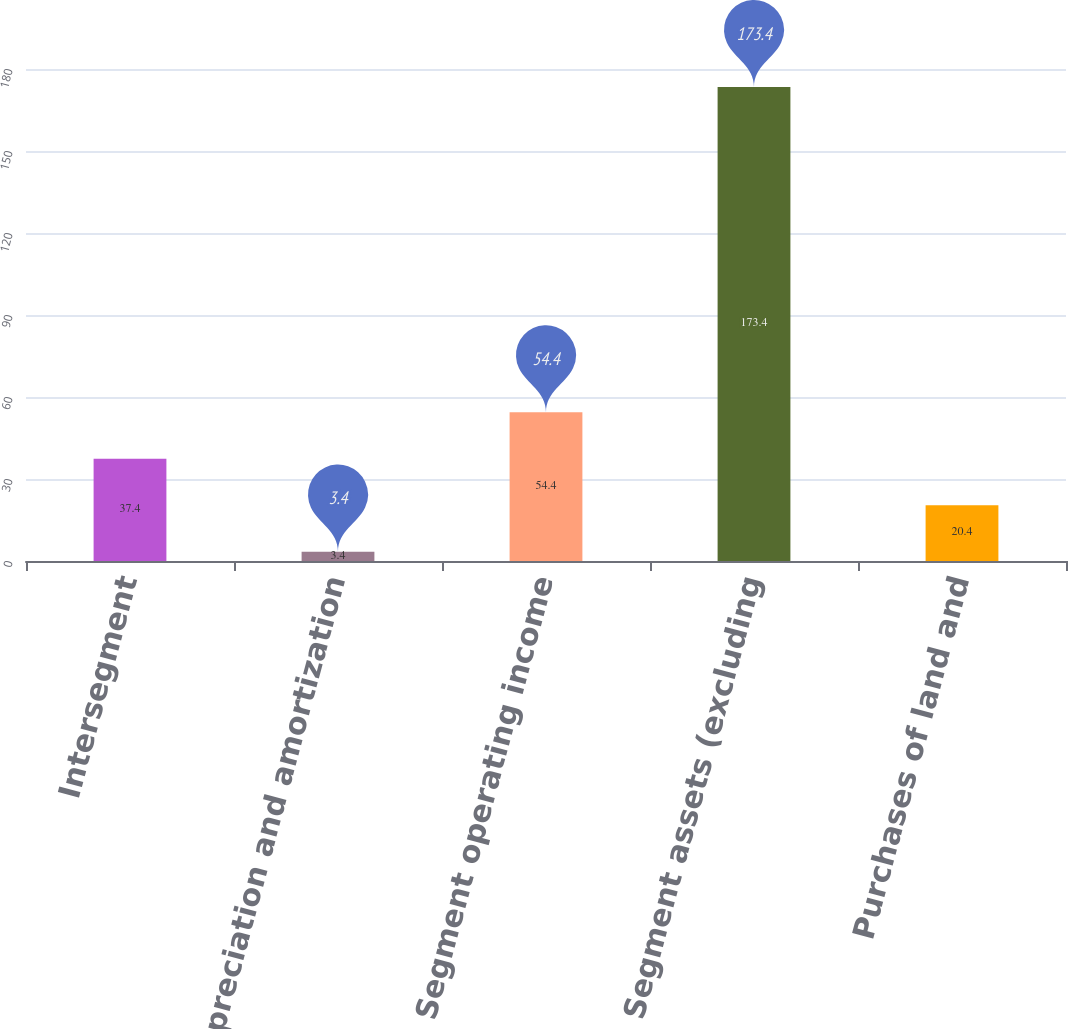Convert chart to OTSL. <chart><loc_0><loc_0><loc_500><loc_500><bar_chart><fcel>Intersegment<fcel>Depreciation and amortization<fcel>Segment operating income<fcel>Segment assets (excluding<fcel>Purchases of land and<nl><fcel>37.4<fcel>3.4<fcel>54.4<fcel>173.4<fcel>20.4<nl></chart> 